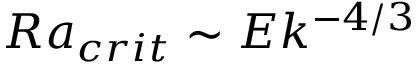<formula> <loc_0><loc_0><loc_500><loc_500>R a _ { c r i t } \sim E k ^ { - 4 / 3 }</formula> 